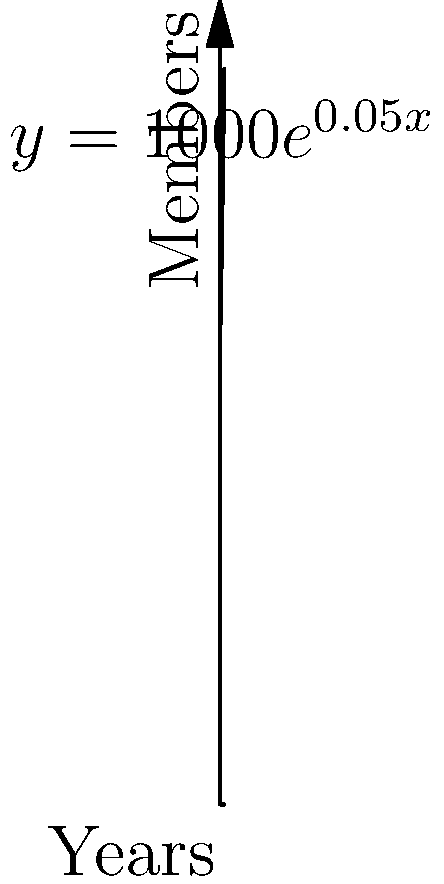As a legal intern studying labor law, you're analyzing union membership growth. A union's membership is modeled by the function $M(t) = 1000e^{0.05t}$, where $M(t)$ is the number of members after $t$ years. How many years will it take for the union's membership to double from its initial size? To solve this problem, we'll follow these steps:

1) The initial membership is when $t = 0$:
   $M(0) = 1000e^{0.05(0)} = 1000$

2) We want to find when the membership becomes 2000:
   $2000 = 1000e^{0.05t}$

3) Divide both sides by 1000:
   $2 = e^{0.05t}$

4) Take the natural log of both sides:
   $\ln(2) = \ln(e^{0.05t})$

5) Simplify the right side using the property of logarithms:
   $\ln(2) = 0.05t$

6) Solve for $t$:
   $t = \frac{\ln(2)}{0.05}$

7) Calculate the result:
   $t = \frac{0.693147...}{0.05} \approx 13.86$ years

Therefore, it will take approximately 13.86 years for the union's membership to double.
Answer: 13.86 years 